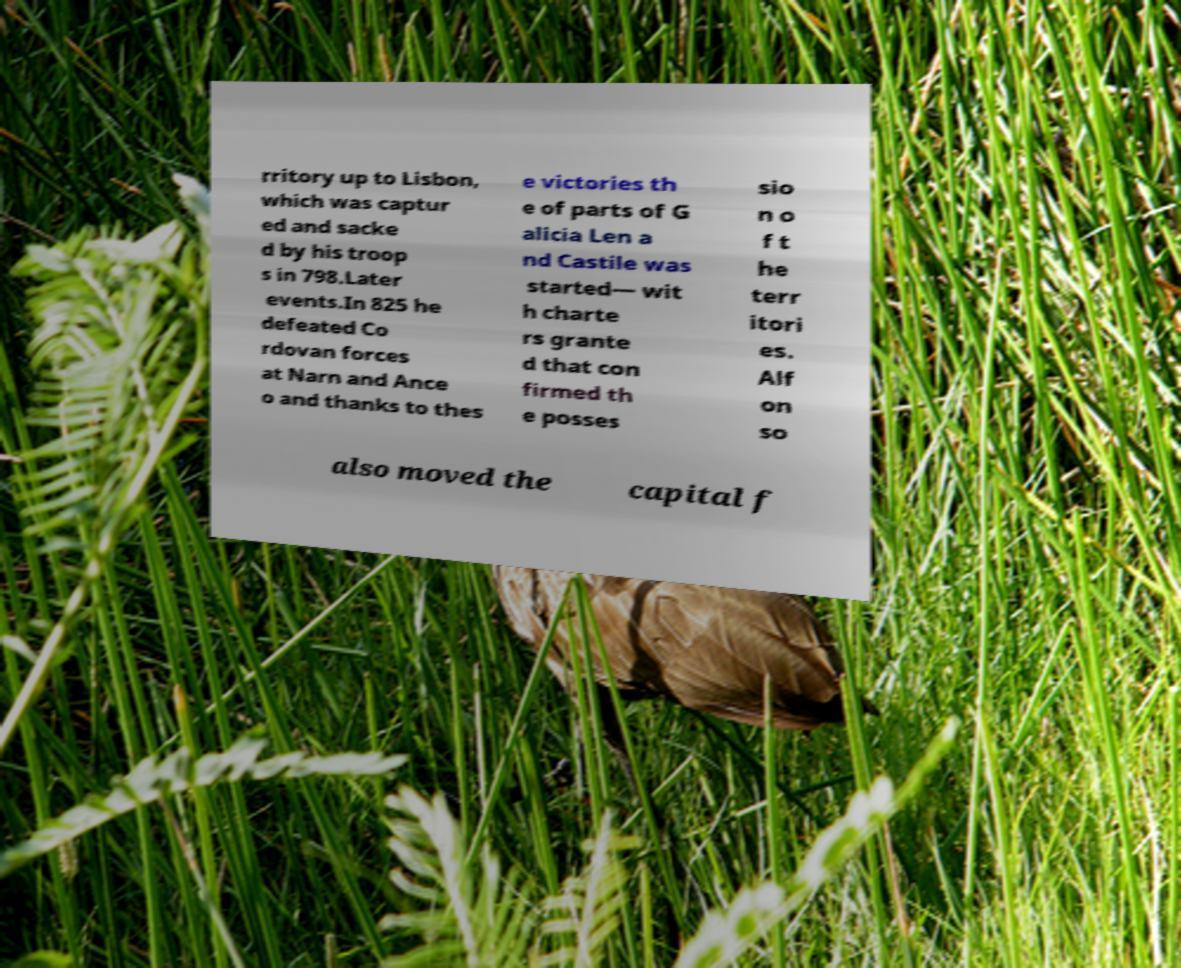Can you accurately transcribe the text from the provided image for me? rritory up to Lisbon, which was captur ed and sacke d by his troop s in 798.Later events.In 825 he defeated Co rdovan forces at Narn and Ance o and thanks to thes e victories th e of parts of G alicia Len a nd Castile was started— wit h charte rs grante d that con firmed th e posses sio n o f t he terr itori es. Alf on so also moved the capital f 